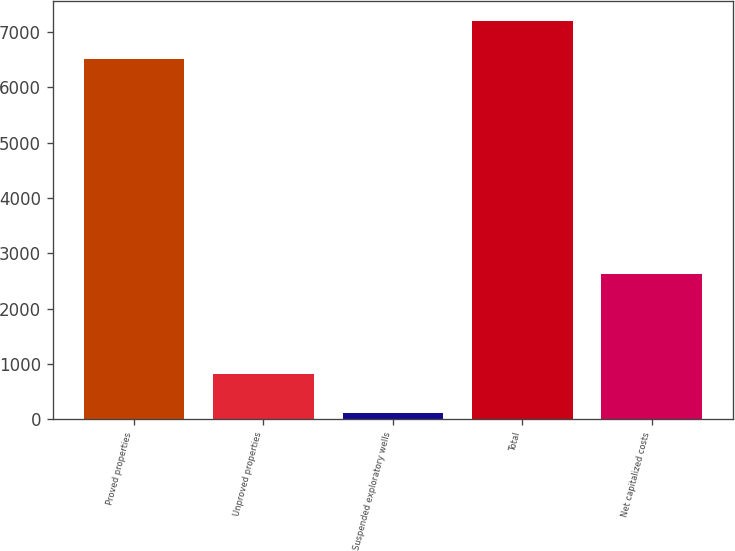Convert chart. <chart><loc_0><loc_0><loc_500><loc_500><bar_chart><fcel>Proved properties<fcel>Unproved properties<fcel>Suspended exploratory wells<fcel>Total<fcel>Net capitalized costs<nl><fcel>6508<fcel>811.2<fcel>115<fcel>7204.2<fcel>2623<nl></chart> 